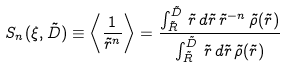Convert formula to latex. <formula><loc_0><loc_0><loc_500><loc_500>S _ { n } ( \xi , { \tilde { D } } ) \equiv \left \langle \frac { 1 } { { \tilde { r } } ^ { n } } \right \rangle = \frac { \int _ { \tilde { R } } ^ { \tilde { D } } \, { \tilde { r } } \, { d } { \tilde { r } } \, { \tilde { r } } ^ { - n } \, { \tilde { \rho } } ( { \tilde { r } } ) } { \int _ { \tilde { R } } ^ { \tilde { D } } \, { \tilde { r } } \, { d } { \tilde { r } } \, { \tilde { \rho } } ( { \tilde { r } } ) }</formula> 